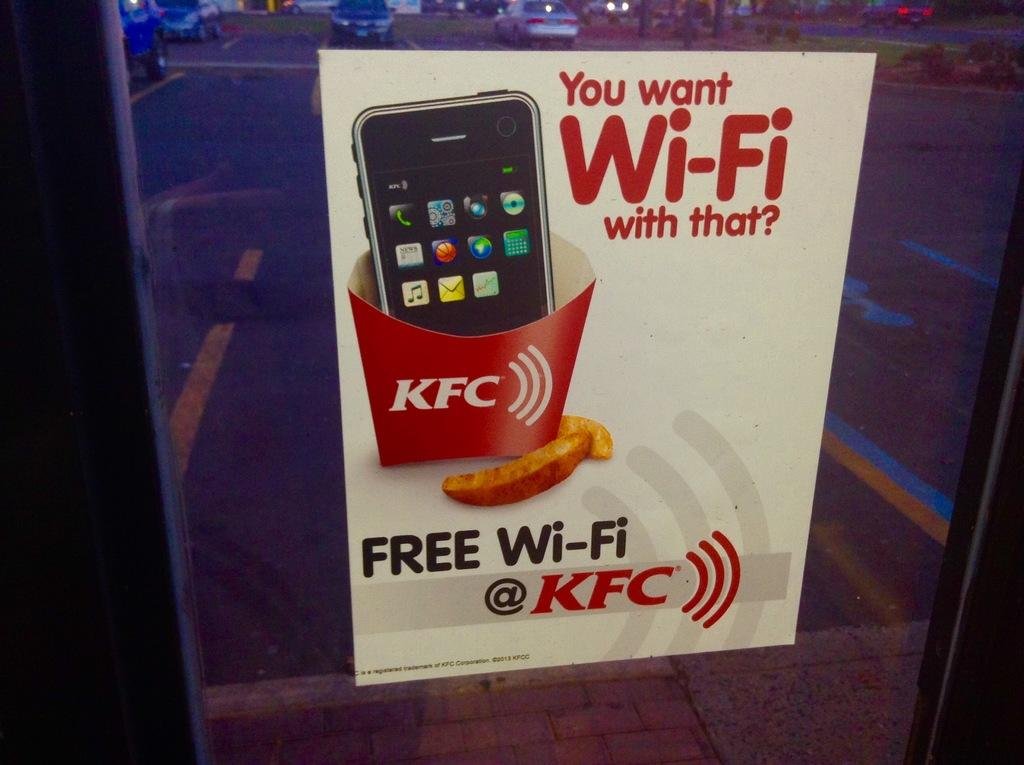<image>
Create a compact narrative representing the image presented. A sign offering free wi-fi at KFC showing a smartphone in a fry container. 